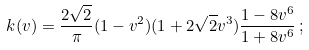Convert formula to latex. <formula><loc_0><loc_0><loc_500><loc_500>k ( v ) = \frac { 2 \sqrt { 2 } } { \pi } ( 1 - v ^ { 2 } ) ( 1 + 2 \sqrt { 2 } v ^ { 3 } ) \frac { 1 - 8 v ^ { 6 } } { 1 + 8 v ^ { 6 } } \, ;</formula> 